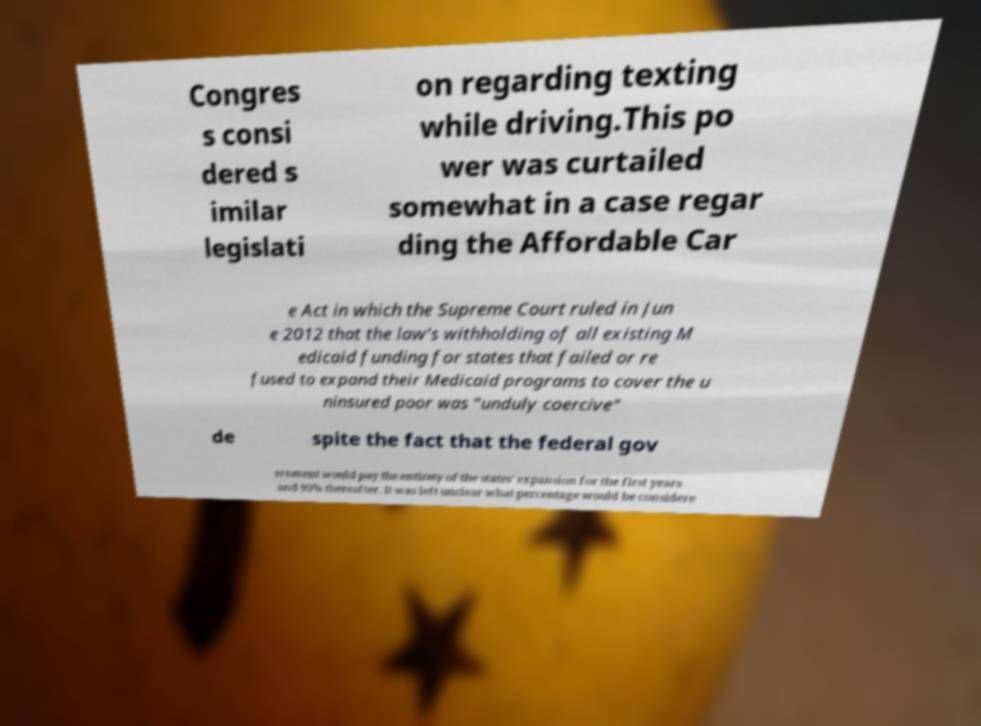Can you read and provide the text displayed in the image?This photo seems to have some interesting text. Can you extract and type it out for me? Congres s consi dered s imilar legislati on regarding texting while driving.This po wer was curtailed somewhat in a case regar ding the Affordable Car e Act in which the Supreme Court ruled in Jun e 2012 that the law's withholding of all existing M edicaid funding for states that failed or re fused to expand their Medicaid programs to cover the u ninsured poor was "unduly coercive" de spite the fact that the federal gov ernment would pay the entirety of the states' expansion for the first years and 90% thereafter. It was left unclear what percentage would be considere 